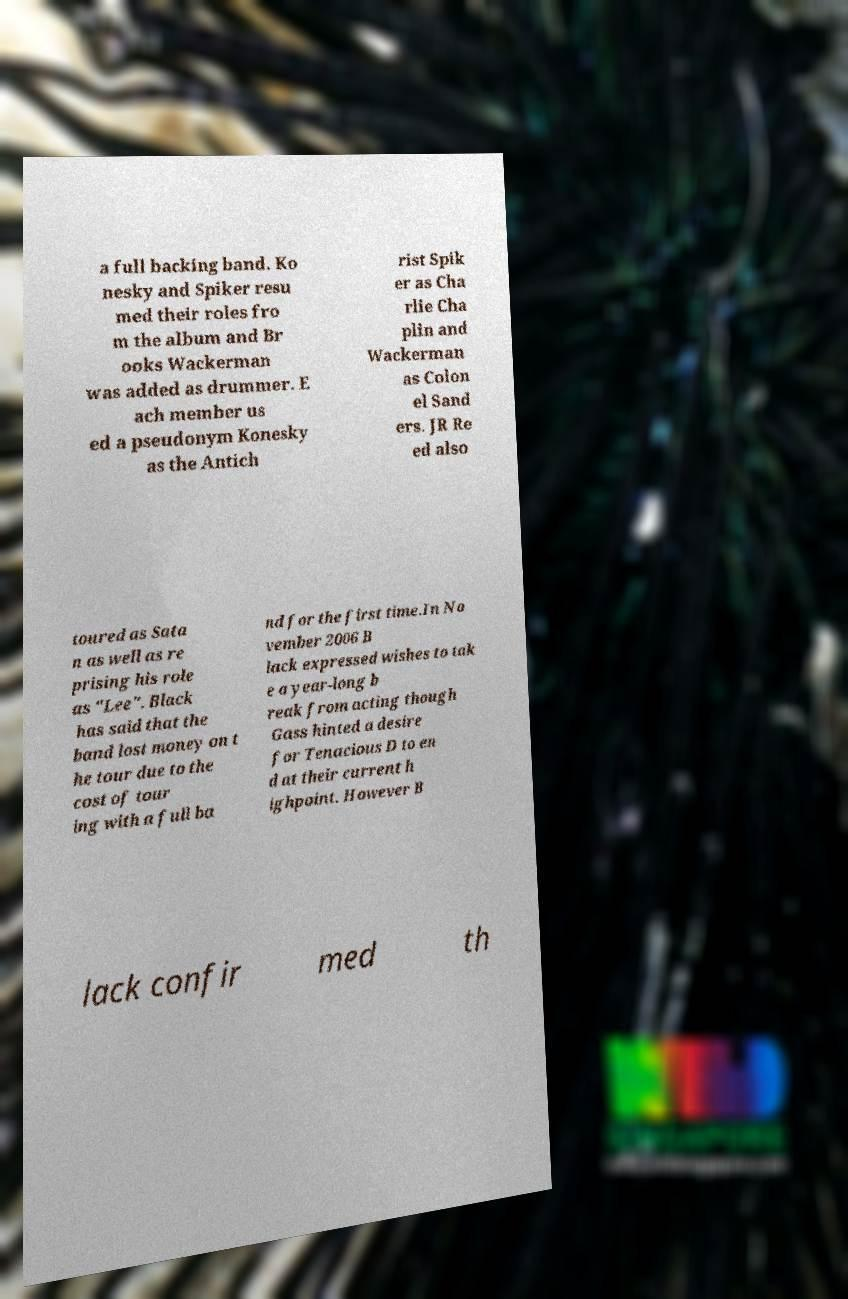Can you accurately transcribe the text from the provided image for me? a full backing band. Ko nesky and Spiker resu med their roles fro m the album and Br ooks Wackerman was added as drummer. E ach member us ed a pseudonym Konesky as the Antich rist Spik er as Cha rlie Cha plin and Wackerman as Colon el Sand ers. JR Re ed also toured as Sata n as well as re prising his role as "Lee". Black has said that the band lost money on t he tour due to the cost of tour ing with a full ba nd for the first time.In No vember 2006 B lack expressed wishes to tak e a year-long b reak from acting though Gass hinted a desire for Tenacious D to en d at their current h ighpoint. However B lack confir med th 